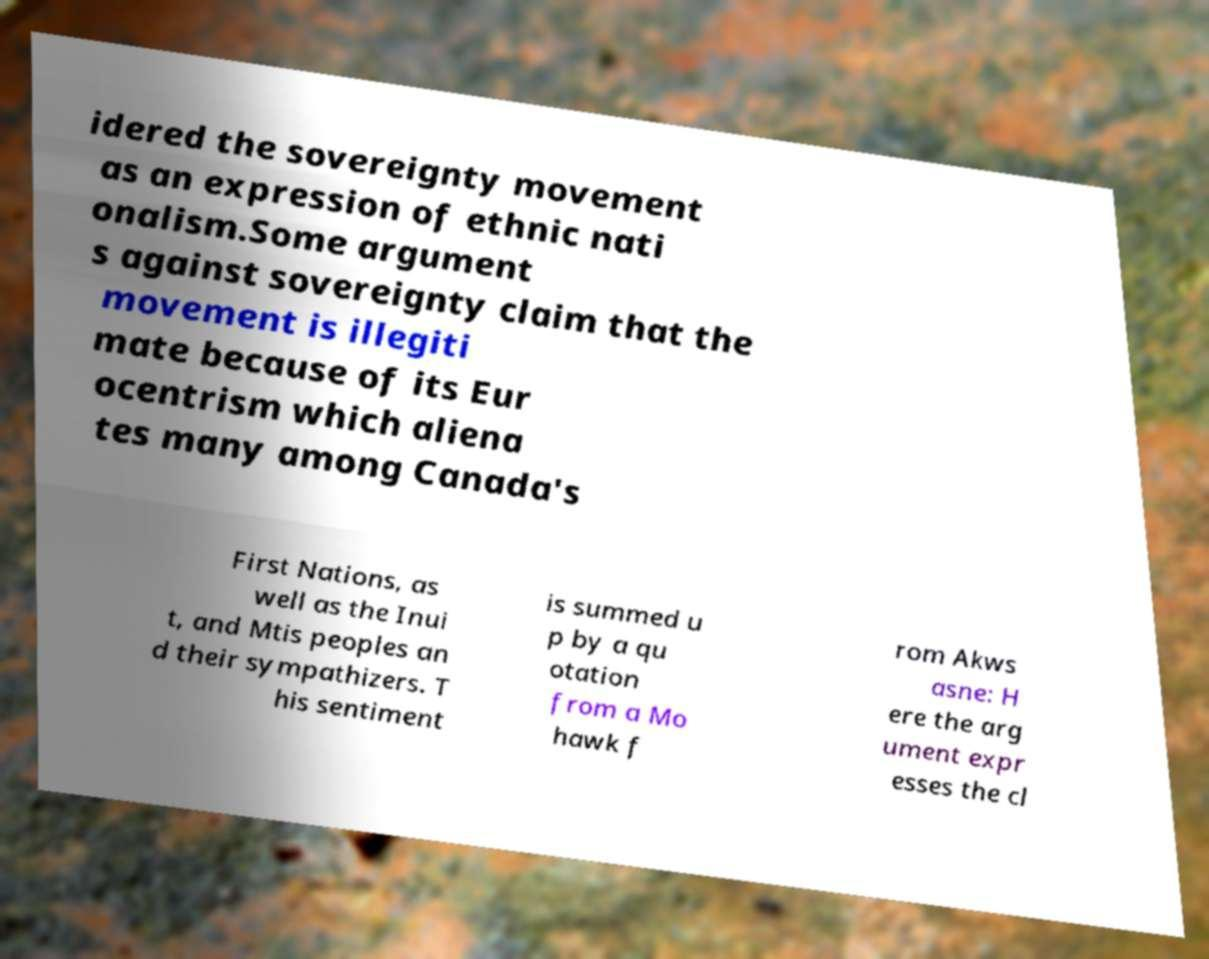Can you read and provide the text displayed in the image?This photo seems to have some interesting text. Can you extract and type it out for me? idered the sovereignty movement as an expression of ethnic nati onalism.Some argument s against sovereignty claim that the movement is illegiti mate because of its Eur ocentrism which aliena tes many among Canada's First Nations, as well as the Inui t, and Mtis peoples an d their sympathizers. T his sentiment is summed u p by a qu otation from a Mo hawk f rom Akws asne: H ere the arg ument expr esses the cl 